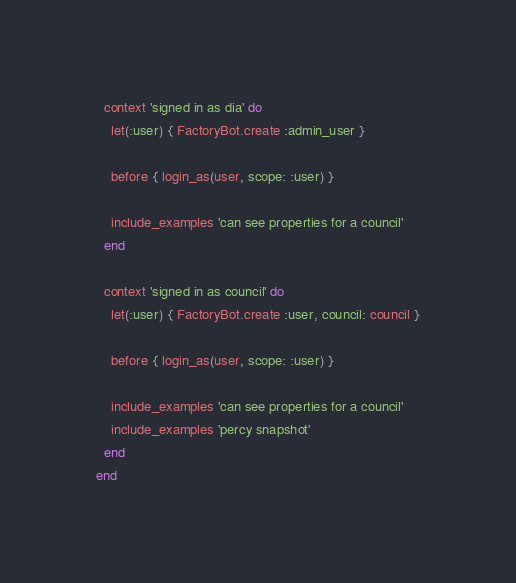<code> <loc_0><loc_0><loc_500><loc_500><_Ruby_>  context 'signed in as dia' do
    let(:user) { FactoryBot.create :admin_user }

    before { login_as(user, scope: :user) }

    include_examples 'can see properties for a council'
  end

  context 'signed in as council' do
    let(:user) { FactoryBot.create :user, council: council }

    before { login_as(user, scope: :user) }

    include_examples 'can see properties for a council'
    include_examples 'percy snapshot'
  end
end
</code> 